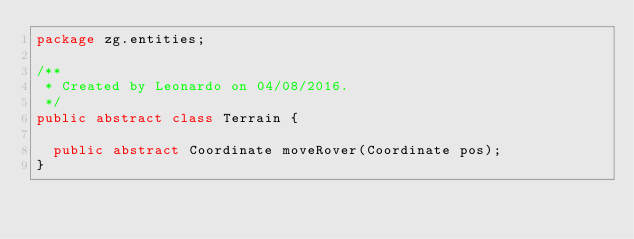<code> <loc_0><loc_0><loc_500><loc_500><_Java_>package zg.entities;

/**
 * Created by Leonardo on 04/08/2016.
 */
public abstract class Terrain {

	public abstract Coordinate moveRover(Coordinate pos);
}
</code> 